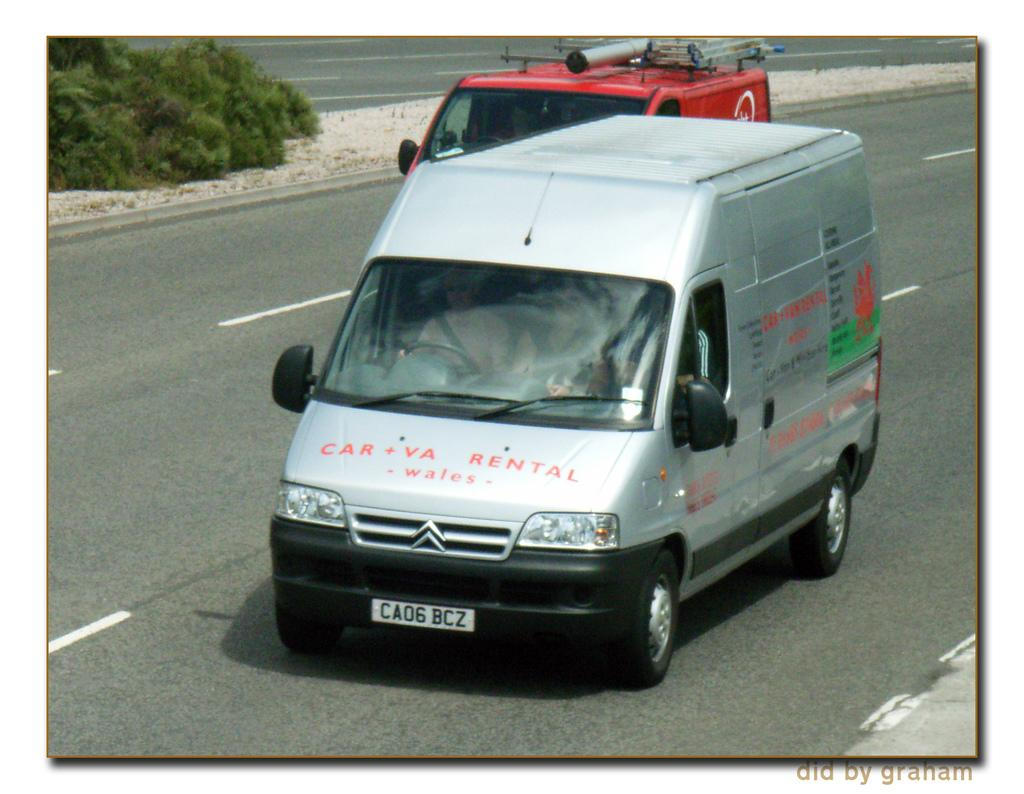What is written on the car in the image? There is a car with text in the image. What type of natural environment is visible in the image? There are trees and sand visible in the image. How many cars can be seen in the image? There are two cars visible in the image, with one behind the other. What type of lettuce is growing in the sand in the image? There is no lettuce present in the image; it features a car with text, trees, sand, and another car. 